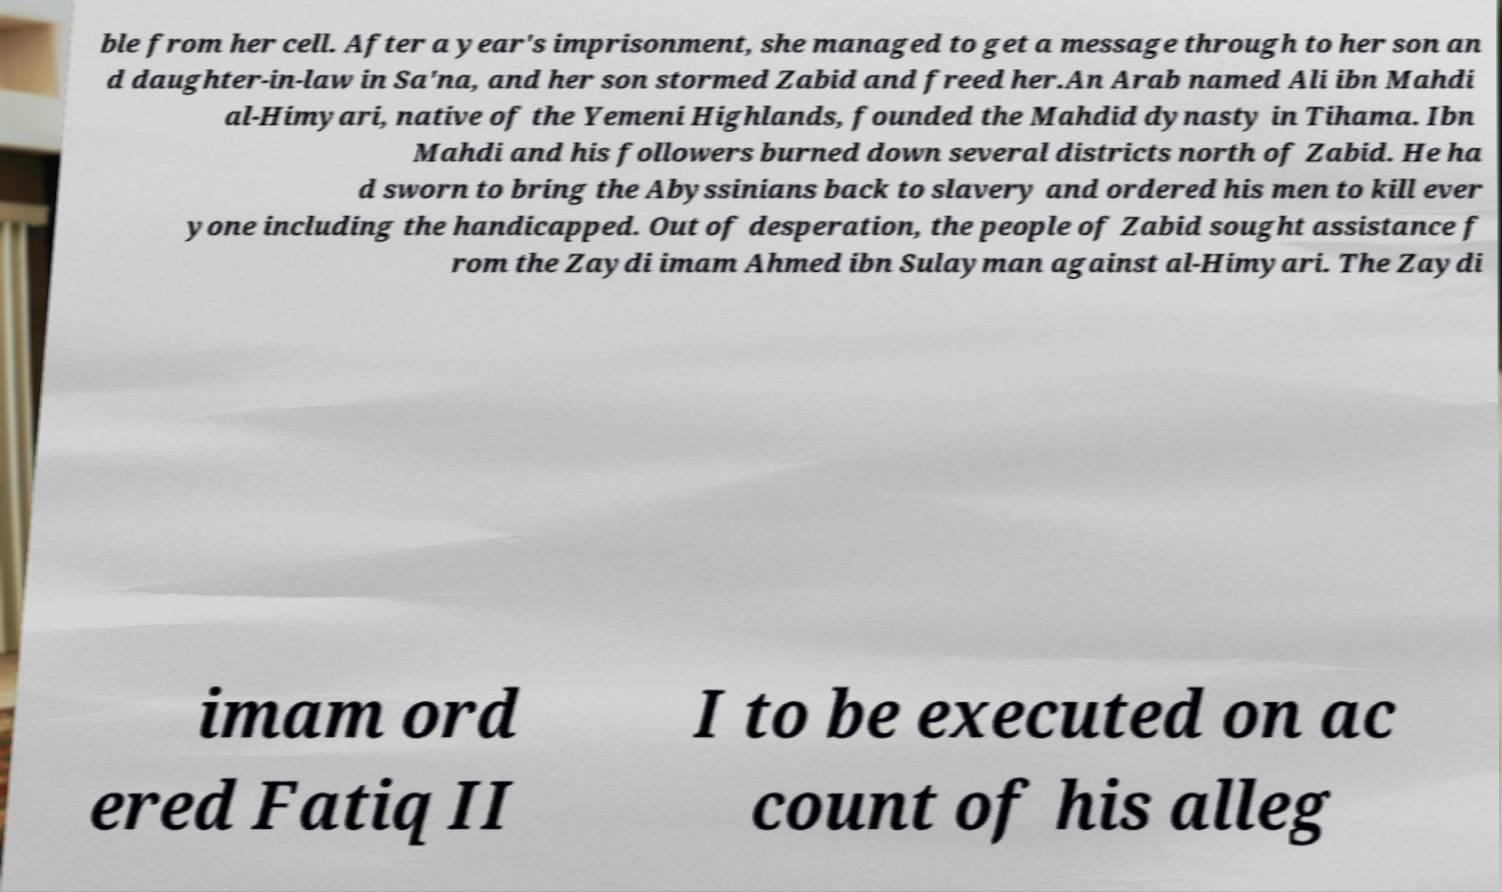There's text embedded in this image that I need extracted. Can you transcribe it verbatim? ble from her cell. After a year's imprisonment, she managed to get a message through to her son an d daughter-in-law in Sa'na, and her son stormed Zabid and freed her.An Arab named Ali ibn Mahdi al-Himyari, native of the Yemeni Highlands, founded the Mahdid dynasty in Tihama. Ibn Mahdi and his followers burned down several districts north of Zabid. He ha d sworn to bring the Abyssinians back to slavery and ordered his men to kill ever yone including the handicapped. Out of desperation, the people of Zabid sought assistance f rom the Zaydi imam Ahmed ibn Sulayman against al-Himyari. The Zaydi imam ord ered Fatiq II I to be executed on ac count of his alleg 